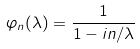<formula> <loc_0><loc_0><loc_500><loc_500>\varphi _ { n } ( \lambda ) = \frac { 1 } { 1 - i n / \lambda }</formula> 